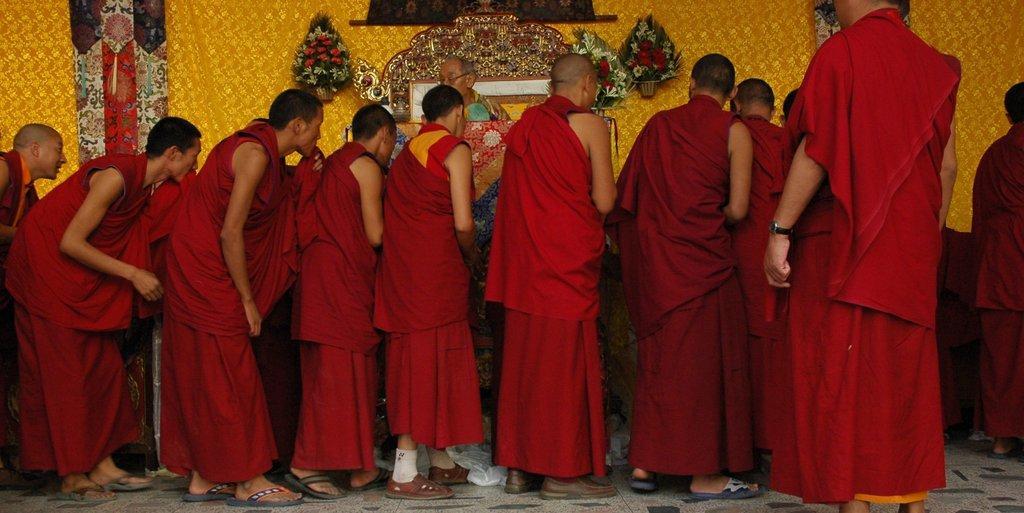Describe this image in one or two sentences. As we can see in the image there is a wall, flowers, table and group of people wearing red color dresses. 